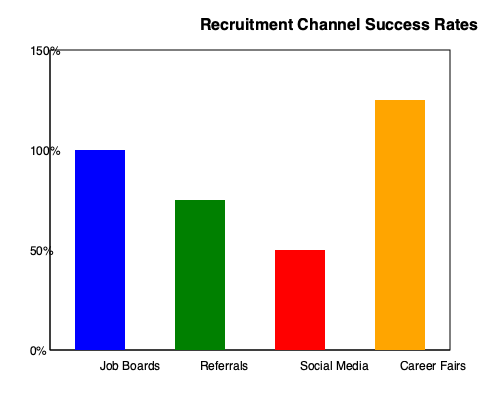As a sales manager evaluating recruitment channels, which channel shows the highest success rate, and by approximately what percentage does it outperform the next best channel? To answer this question, we need to follow these steps:

1. Identify the recruitment channels shown in the graph:
   - Job Boards
   - Referrals
   - Social Media
   - Career Fairs

2. Determine the success rate for each channel by estimating the height of each bar:
   - Job Boards: ~100%
   - Referrals: ~75%
   - Social Media: ~50%
   - Career Fairs: ~125%

3. Identify the channel with the highest success rate:
   Career Fairs has the highest bar, reaching approximately 125%.

4. Identify the second-best performing channel:
   Job Boards is the second-highest, reaching approximately 100%.

5. Calculate the difference between the top two channels:
   $125\% - 100\% = 25\%$

Therefore, Career Fairs shows the highest success rate and outperforms the next best channel (Job Boards) by approximately 25%.
Answer: Career Fairs; 25% 